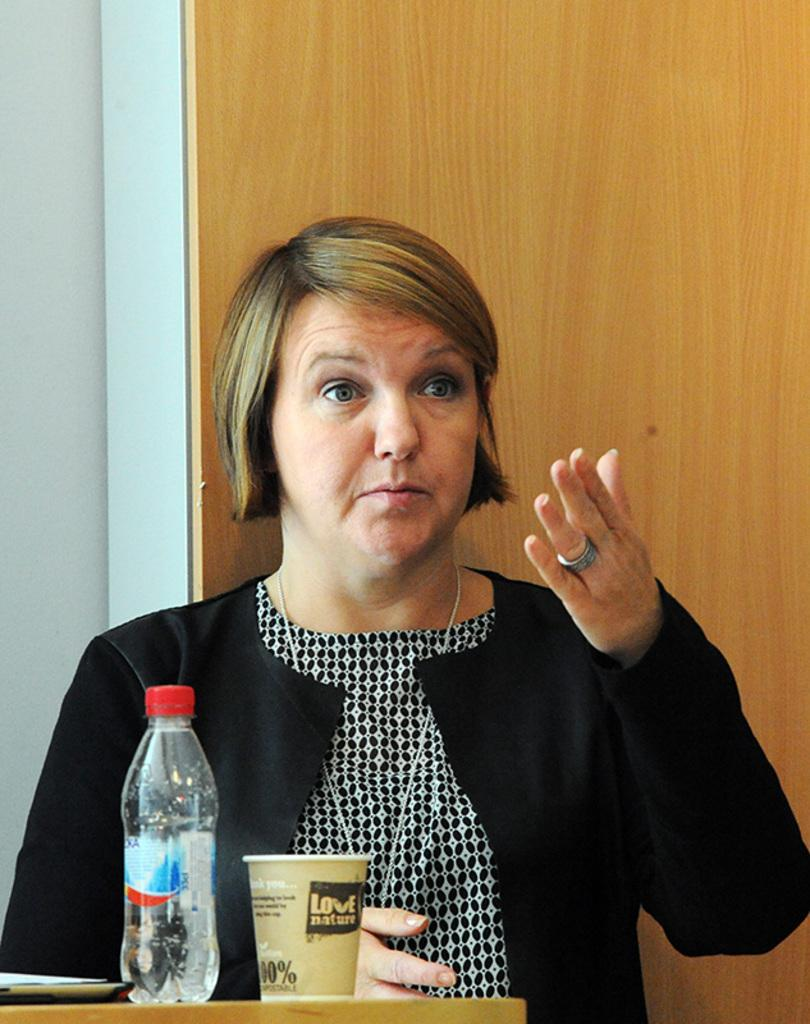Who is present in the image? There is a woman in the image. What is the woman doing with her hands? The woman is pointing her hands. What can be seen on the table in the image? There is a glass and a bottle on the table. What is visible in the background of the image? There is a wall in the background of the image. What type of oatmeal is being served on the table in the image? There is no oatmeal present in the image; only a glass and a bottle are visible on the table. 